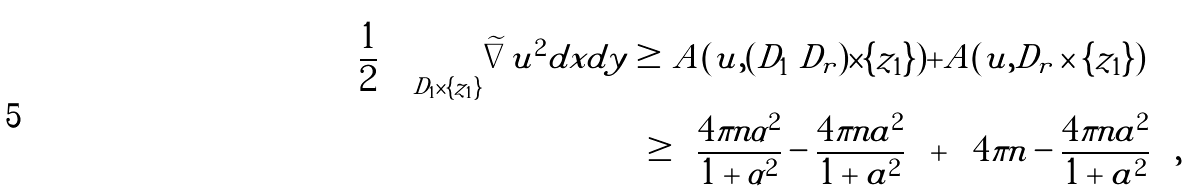<formula> <loc_0><loc_0><loc_500><loc_500>\frac { 1 } { 2 } \int _ { D _ { 1 } \times \{ z _ { 1 } \} } | \widetilde { \nabla } u | ^ { 2 } d x d y \geq & A ( u , ( D _ { 1 } \ D _ { r } ) \times \{ z _ { 1 } \} ) + A ( u , D _ { r } \times \{ z _ { 1 } \} ) \\ \geq & \left ( \frac { 4 \pi n \alpha ^ { 2 } } { 1 + \alpha ^ { 2 } } - \frac { 4 \pi n a ^ { 2 } } { 1 + a ^ { 2 } } \right ) + \left ( 4 \pi n - \frac { 4 \pi n a ^ { 2 } } { 1 + a ^ { 2 } } \right ) ,</formula> 